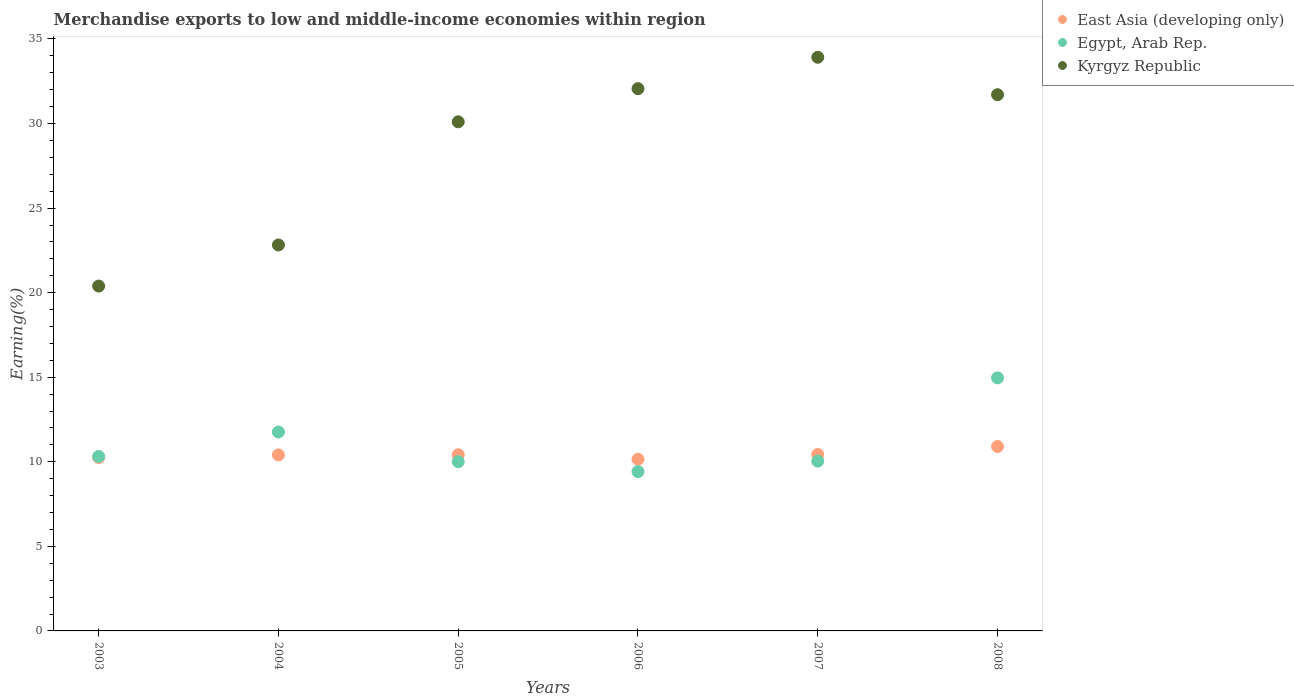What is the percentage of amount earned from merchandise exports in East Asia (developing only) in 2007?
Give a very brief answer. 10.44. Across all years, what is the maximum percentage of amount earned from merchandise exports in Egypt, Arab Rep.?
Give a very brief answer. 14.96. Across all years, what is the minimum percentage of amount earned from merchandise exports in East Asia (developing only)?
Give a very brief answer. 10.15. In which year was the percentage of amount earned from merchandise exports in East Asia (developing only) minimum?
Provide a short and direct response. 2006. What is the total percentage of amount earned from merchandise exports in Egypt, Arab Rep. in the graph?
Give a very brief answer. 66.51. What is the difference between the percentage of amount earned from merchandise exports in Kyrgyz Republic in 2003 and that in 2008?
Offer a very short reply. -11.32. What is the difference between the percentage of amount earned from merchandise exports in Egypt, Arab Rep. in 2004 and the percentage of amount earned from merchandise exports in Kyrgyz Republic in 2005?
Your answer should be very brief. -18.34. What is the average percentage of amount earned from merchandise exports in Kyrgyz Republic per year?
Provide a succinct answer. 28.5. In the year 2008, what is the difference between the percentage of amount earned from merchandise exports in East Asia (developing only) and percentage of amount earned from merchandise exports in Egypt, Arab Rep.?
Give a very brief answer. -4.06. In how many years, is the percentage of amount earned from merchandise exports in Kyrgyz Republic greater than 8 %?
Your answer should be very brief. 6. What is the ratio of the percentage of amount earned from merchandise exports in Egypt, Arab Rep. in 2005 to that in 2008?
Your response must be concise. 0.67. Is the percentage of amount earned from merchandise exports in Egypt, Arab Rep. in 2005 less than that in 2007?
Your answer should be compact. Yes. Is the difference between the percentage of amount earned from merchandise exports in East Asia (developing only) in 2006 and 2008 greater than the difference between the percentage of amount earned from merchandise exports in Egypt, Arab Rep. in 2006 and 2008?
Your answer should be very brief. Yes. What is the difference between the highest and the second highest percentage of amount earned from merchandise exports in Kyrgyz Republic?
Offer a terse response. 1.85. What is the difference between the highest and the lowest percentage of amount earned from merchandise exports in East Asia (developing only)?
Provide a succinct answer. 0.75. Is the sum of the percentage of amount earned from merchandise exports in Kyrgyz Republic in 2003 and 2005 greater than the maximum percentage of amount earned from merchandise exports in East Asia (developing only) across all years?
Provide a succinct answer. Yes. Does the percentage of amount earned from merchandise exports in East Asia (developing only) monotonically increase over the years?
Offer a terse response. No. How many years are there in the graph?
Provide a short and direct response. 6. Are the values on the major ticks of Y-axis written in scientific E-notation?
Offer a very short reply. No. Does the graph contain grids?
Your response must be concise. No. What is the title of the graph?
Ensure brevity in your answer.  Merchandise exports to low and middle-income economies within region. Does "Micronesia" appear as one of the legend labels in the graph?
Provide a short and direct response. No. What is the label or title of the Y-axis?
Your response must be concise. Earning(%). What is the Earning(%) of East Asia (developing only) in 2003?
Your answer should be very brief. 10.25. What is the Earning(%) in Egypt, Arab Rep. in 2003?
Your answer should be very brief. 10.31. What is the Earning(%) of Kyrgyz Republic in 2003?
Make the answer very short. 20.39. What is the Earning(%) of East Asia (developing only) in 2004?
Ensure brevity in your answer.  10.41. What is the Earning(%) of Egypt, Arab Rep. in 2004?
Give a very brief answer. 11.76. What is the Earning(%) in Kyrgyz Republic in 2004?
Ensure brevity in your answer.  22.82. What is the Earning(%) of East Asia (developing only) in 2005?
Your answer should be very brief. 10.42. What is the Earning(%) of Egypt, Arab Rep. in 2005?
Make the answer very short. 10.01. What is the Earning(%) in Kyrgyz Republic in 2005?
Give a very brief answer. 30.1. What is the Earning(%) of East Asia (developing only) in 2006?
Provide a succinct answer. 10.15. What is the Earning(%) in Egypt, Arab Rep. in 2006?
Your response must be concise. 9.42. What is the Earning(%) in Kyrgyz Republic in 2006?
Your answer should be very brief. 32.06. What is the Earning(%) in East Asia (developing only) in 2007?
Your response must be concise. 10.44. What is the Earning(%) of Egypt, Arab Rep. in 2007?
Your answer should be compact. 10.04. What is the Earning(%) of Kyrgyz Republic in 2007?
Your answer should be very brief. 33.92. What is the Earning(%) of East Asia (developing only) in 2008?
Keep it short and to the point. 10.9. What is the Earning(%) in Egypt, Arab Rep. in 2008?
Provide a short and direct response. 14.96. What is the Earning(%) of Kyrgyz Republic in 2008?
Keep it short and to the point. 31.71. Across all years, what is the maximum Earning(%) of East Asia (developing only)?
Make the answer very short. 10.9. Across all years, what is the maximum Earning(%) of Egypt, Arab Rep.?
Your response must be concise. 14.96. Across all years, what is the maximum Earning(%) of Kyrgyz Republic?
Make the answer very short. 33.92. Across all years, what is the minimum Earning(%) in East Asia (developing only)?
Your answer should be very brief. 10.15. Across all years, what is the minimum Earning(%) of Egypt, Arab Rep.?
Keep it short and to the point. 9.42. Across all years, what is the minimum Earning(%) in Kyrgyz Republic?
Give a very brief answer. 20.39. What is the total Earning(%) in East Asia (developing only) in the graph?
Your answer should be compact. 62.56. What is the total Earning(%) in Egypt, Arab Rep. in the graph?
Your response must be concise. 66.51. What is the total Earning(%) of Kyrgyz Republic in the graph?
Provide a succinct answer. 171. What is the difference between the Earning(%) in East Asia (developing only) in 2003 and that in 2004?
Provide a succinct answer. -0.16. What is the difference between the Earning(%) of Egypt, Arab Rep. in 2003 and that in 2004?
Your answer should be compact. -1.45. What is the difference between the Earning(%) of Kyrgyz Republic in 2003 and that in 2004?
Offer a very short reply. -2.43. What is the difference between the Earning(%) in East Asia (developing only) in 2003 and that in 2005?
Keep it short and to the point. -0.17. What is the difference between the Earning(%) in Egypt, Arab Rep. in 2003 and that in 2005?
Ensure brevity in your answer.  0.31. What is the difference between the Earning(%) in Kyrgyz Republic in 2003 and that in 2005?
Offer a very short reply. -9.71. What is the difference between the Earning(%) in East Asia (developing only) in 2003 and that in 2006?
Keep it short and to the point. 0.1. What is the difference between the Earning(%) of Egypt, Arab Rep. in 2003 and that in 2006?
Ensure brevity in your answer.  0.89. What is the difference between the Earning(%) in Kyrgyz Republic in 2003 and that in 2006?
Make the answer very short. -11.67. What is the difference between the Earning(%) of East Asia (developing only) in 2003 and that in 2007?
Provide a short and direct response. -0.19. What is the difference between the Earning(%) of Egypt, Arab Rep. in 2003 and that in 2007?
Ensure brevity in your answer.  0.27. What is the difference between the Earning(%) of Kyrgyz Republic in 2003 and that in 2007?
Provide a succinct answer. -13.53. What is the difference between the Earning(%) in East Asia (developing only) in 2003 and that in 2008?
Keep it short and to the point. -0.65. What is the difference between the Earning(%) in Egypt, Arab Rep. in 2003 and that in 2008?
Your answer should be very brief. -4.65. What is the difference between the Earning(%) in Kyrgyz Republic in 2003 and that in 2008?
Your response must be concise. -11.32. What is the difference between the Earning(%) of East Asia (developing only) in 2004 and that in 2005?
Your answer should be compact. -0.01. What is the difference between the Earning(%) in Egypt, Arab Rep. in 2004 and that in 2005?
Make the answer very short. 1.76. What is the difference between the Earning(%) in Kyrgyz Republic in 2004 and that in 2005?
Give a very brief answer. -7.28. What is the difference between the Earning(%) in East Asia (developing only) in 2004 and that in 2006?
Provide a succinct answer. 0.25. What is the difference between the Earning(%) in Egypt, Arab Rep. in 2004 and that in 2006?
Your response must be concise. 2.34. What is the difference between the Earning(%) of Kyrgyz Republic in 2004 and that in 2006?
Ensure brevity in your answer.  -9.24. What is the difference between the Earning(%) in East Asia (developing only) in 2004 and that in 2007?
Give a very brief answer. -0.03. What is the difference between the Earning(%) of Egypt, Arab Rep. in 2004 and that in 2007?
Ensure brevity in your answer.  1.72. What is the difference between the Earning(%) of Kyrgyz Republic in 2004 and that in 2007?
Offer a very short reply. -11.1. What is the difference between the Earning(%) of East Asia (developing only) in 2004 and that in 2008?
Make the answer very short. -0.5. What is the difference between the Earning(%) in Egypt, Arab Rep. in 2004 and that in 2008?
Your answer should be compact. -3.2. What is the difference between the Earning(%) of Kyrgyz Republic in 2004 and that in 2008?
Your answer should be compact. -8.89. What is the difference between the Earning(%) in East Asia (developing only) in 2005 and that in 2006?
Your answer should be compact. 0.27. What is the difference between the Earning(%) of Egypt, Arab Rep. in 2005 and that in 2006?
Provide a short and direct response. 0.58. What is the difference between the Earning(%) in Kyrgyz Republic in 2005 and that in 2006?
Provide a succinct answer. -1.96. What is the difference between the Earning(%) in East Asia (developing only) in 2005 and that in 2007?
Your answer should be very brief. -0.02. What is the difference between the Earning(%) of Egypt, Arab Rep. in 2005 and that in 2007?
Give a very brief answer. -0.04. What is the difference between the Earning(%) in Kyrgyz Republic in 2005 and that in 2007?
Your response must be concise. -3.81. What is the difference between the Earning(%) in East Asia (developing only) in 2005 and that in 2008?
Keep it short and to the point. -0.48. What is the difference between the Earning(%) in Egypt, Arab Rep. in 2005 and that in 2008?
Offer a very short reply. -4.96. What is the difference between the Earning(%) of Kyrgyz Republic in 2005 and that in 2008?
Provide a succinct answer. -1.6. What is the difference between the Earning(%) of East Asia (developing only) in 2006 and that in 2007?
Your answer should be compact. -0.28. What is the difference between the Earning(%) of Egypt, Arab Rep. in 2006 and that in 2007?
Offer a very short reply. -0.62. What is the difference between the Earning(%) in Kyrgyz Republic in 2006 and that in 2007?
Provide a succinct answer. -1.85. What is the difference between the Earning(%) of East Asia (developing only) in 2006 and that in 2008?
Make the answer very short. -0.75. What is the difference between the Earning(%) of Egypt, Arab Rep. in 2006 and that in 2008?
Make the answer very short. -5.54. What is the difference between the Earning(%) of Kyrgyz Republic in 2006 and that in 2008?
Your answer should be very brief. 0.36. What is the difference between the Earning(%) in East Asia (developing only) in 2007 and that in 2008?
Offer a very short reply. -0.47. What is the difference between the Earning(%) of Egypt, Arab Rep. in 2007 and that in 2008?
Provide a succinct answer. -4.92. What is the difference between the Earning(%) in Kyrgyz Republic in 2007 and that in 2008?
Give a very brief answer. 2.21. What is the difference between the Earning(%) of East Asia (developing only) in 2003 and the Earning(%) of Egypt, Arab Rep. in 2004?
Ensure brevity in your answer.  -1.51. What is the difference between the Earning(%) in East Asia (developing only) in 2003 and the Earning(%) in Kyrgyz Republic in 2004?
Your answer should be compact. -12.57. What is the difference between the Earning(%) of Egypt, Arab Rep. in 2003 and the Earning(%) of Kyrgyz Republic in 2004?
Your response must be concise. -12.51. What is the difference between the Earning(%) in East Asia (developing only) in 2003 and the Earning(%) in Egypt, Arab Rep. in 2005?
Your answer should be compact. 0.24. What is the difference between the Earning(%) in East Asia (developing only) in 2003 and the Earning(%) in Kyrgyz Republic in 2005?
Provide a succinct answer. -19.85. What is the difference between the Earning(%) in Egypt, Arab Rep. in 2003 and the Earning(%) in Kyrgyz Republic in 2005?
Offer a terse response. -19.79. What is the difference between the Earning(%) in East Asia (developing only) in 2003 and the Earning(%) in Egypt, Arab Rep. in 2006?
Your answer should be compact. 0.83. What is the difference between the Earning(%) of East Asia (developing only) in 2003 and the Earning(%) of Kyrgyz Republic in 2006?
Make the answer very short. -21.81. What is the difference between the Earning(%) in Egypt, Arab Rep. in 2003 and the Earning(%) in Kyrgyz Republic in 2006?
Provide a short and direct response. -21.75. What is the difference between the Earning(%) of East Asia (developing only) in 2003 and the Earning(%) of Egypt, Arab Rep. in 2007?
Ensure brevity in your answer.  0.21. What is the difference between the Earning(%) of East Asia (developing only) in 2003 and the Earning(%) of Kyrgyz Republic in 2007?
Your answer should be compact. -23.67. What is the difference between the Earning(%) of Egypt, Arab Rep. in 2003 and the Earning(%) of Kyrgyz Republic in 2007?
Give a very brief answer. -23.6. What is the difference between the Earning(%) of East Asia (developing only) in 2003 and the Earning(%) of Egypt, Arab Rep. in 2008?
Give a very brief answer. -4.71. What is the difference between the Earning(%) in East Asia (developing only) in 2003 and the Earning(%) in Kyrgyz Republic in 2008?
Provide a short and direct response. -21.46. What is the difference between the Earning(%) of Egypt, Arab Rep. in 2003 and the Earning(%) of Kyrgyz Republic in 2008?
Your answer should be compact. -21.39. What is the difference between the Earning(%) of East Asia (developing only) in 2004 and the Earning(%) of Egypt, Arab Rep. in 2005?
Provide a short and direct response. 0.4. What is the difference between the Earning(%) of East Asia (developing only) in 2004 and the Earning(%) of Kyrgyz Republic in 2005?
Provide a succinct answer. -19.7. What is the difference between the Earning(%) in Egypt, Arab Rep. in 2004 and the Earning(%) in Kyrgyz Republic in 2005?
Make the answer very short. -18.34. What is the difference between the Earning(%) of East Asia (developing only) in 2004 and the Earning(%) of Egypt, Arab Rep. in 2006?
Give a very brief answer. 0.98. What is the difference between the Earning(%) of East Asia (developing only) in 2004 and the Earning(%) of Kyrgyz Republic in 2006?
Your answer should be very brief. -21.66. What is the difference between the Earning(%) of Egypt, Arab Rep. in 2004 and the Earning(%) of Kyrgyz Republic in 2006?
Give a very brief answer. -20.3. What is the difference between the Earning(%) in East Asia (developing only) in 2004 and the Earning(%) in Egypt, Arab Rep. in 2007?
Provide a succinct answer. 0.36. What is the difference between the Earning(%) of East Asia (developing only) in 2004 and the Earning(%) of Kyrgyz Republic in 2007?
Give a very brief answer. -23.51. What is the difference between the Earning(%) of Egypt, Arab Rep. in 2004 and the Earning(%) of Kyrgyz Republic in 2007?
Your answer should be compact. -22.16. What is the difference between the Earning(%) of East Asia (developing only) in 2004 and the Earning(%) of Egypt, Arab Rep. in 2008?
Provide a succinct answer. -4.56. What is the difference between the Earning(%) of East Asia (developing only) in 2004 and the Earning(%) of Kyrgyz Republic in 2008?
Ensure brevity in your answer.  -21.3. What is the difference between the Earning(%) of Egypt, Arab Rep. in 2004 and the Earning(%) of Kyrgyz Republic in 2008?
Keep it short and to the point. -19.94. What is the difference between the Earning(%) of East Asia (developing only) in 2005 and the Earning(%) of Egypt, Arab Rep. in 2006?
Make the answer very short. 1. What is the difference between the Earning(%) of East Asia (developing only) in 2005 and the Earning(%) of Kyrgyz Republic in 2006?
Offer a terse response. -21.64. What is the difference between the Earning(%) of Egypt, Arab Rep. in 2005 and the Earning(%) of Kyrgyz Republic in 2006?
Your answer should be compact. -22.06. What is the difference between the Earning(%) in East Asia (developing only) in 2005 and the Earning(%) in Egypt, Arab Rep. in 2007?
Make the answer very short. 0.38. What is the difference between the Earning(%) of East Asia (developing only) in 2005 and the Earning(%) of Kyrgyz Republic in 2007?
Provide a succinct answer. -23.5. What is the difference between the Earning(%) of Egypt, Arab Rep. in 2005 and the Earning(%) of Kyrgyz Republic in 2007?
Your answer should be compact. -23.91. What is the difference between the Earning(%) in East Asia (developing only) in 2005 and the Earning(%) in Egypt, Arab Rep. in 2008?
Make the answer very short. -4.54. What is the difference between the Earning(%) in East Asia (developing only) in 2005 and the Earning(%) in Kyrgyz Republic in 2008?
Provide a short and direct response. -21.29. What is the difference between the Earning(%) of Egypt, Arab Rep. in 2005 and the Earning(%) of Kyrgyz Republic in 2008?
Ensure brevity in your answer.  -21.7. What is the difference between the Earning(%) of East Asia (developing only) in 2006 and the Earning(%) of Egypt, Arab Rep. in 2007?
Offer a terse response. 0.11. What is the difference between the Earning(%) of East Asia (developing only) in 2006 and the Earning(%) of Kyrgyz Republic in 2007?
Provide a succinct answer. -23.77. What is the difference between the Earning(%) of Egypt, Arab Rep. in 2006 and the Earning(%) of Kyrgyz Republic in 2007?
Your answer should be very brief. -24.5. What is the difference between the Earning(%) in East Asia (developing only) in 2006 and the Earning(%) in Egypt, Arab Rep. in 2008?
Your answer should be compact. -4.81. What is the difference between the Earning(%) of East Asia (developing only) in 2006 and the Earning(%) of Kyrgyz Republic in 2008?
Offer a terse response. -21.55. What is the difference between the Earning(%) in Egypt, Arab Rep. in 2006 and the Earning(%) in Kyrgyz Republic in 2008?
Give a very brief answer. -22.28. What is the difference between the Earning(%) in East Asia (developing only) in 2007 and the Earning(%) in Egypt, Arab Rep. in 2008?
Your answer should be compact. -4.53. What is the difference between the Earning(%) of East Asia (developing only) in 2007 and the Earning(%) of Kyrgyz Republic in 2008?
Provide a succinct answer. -21.27. What is the difference between the Earning(%) in Egypt, Arab Rep. in 2007 and the Earning(%) in Kyrgyz Republic in 2008?
Offer a terse response. -21.66. What is the average Earning(%) in East Asia (developing only) per year?
Your response must be concise. 10.43. What is the average Earning(%) in Egypt, Arab Rep. per year?
Your response must be concise. 11.08. What is the average Earning(%) of Kyrgyz Republic per year?
Provide a short and direct response. 28.5. In the year 2003, what is the difference between the Earning(%) of East Asia (developing only) and Earning(%) of Egypt, Arab Rep.?
Make the answer very short. -0.07. In the year 2003, what is the difference between the Earning(%) of East Asia (developing only) and Earning(%) of Kyrgyz Republic?
Keep it short and to the point. -10.14. In the year 2003, what is the difference between the Earning(%) of Egypt, Arab Rep. and Earning(%) of Kyrgyz Republic?
Keep it short and to the point. -10.08. In the year 2004, what is the difference between the Earning(%) of East Asia (developing only) and Earning(%) of Egypt, Arab Rep.?
Ensure brevity in your answer.  -1.36. In the year 2004, what is the difference between the Earning(%) in East Asia (developing only) and Earning(%) in Kyrgyz Republic?
Give a very brief answer. -12.41. In the year 2004, what is the difference between the Earning(%) of Egypt, Arab Rep. and Earning(%) of Kyrgyz Republic?
Your response must be concise. -11.06. In the year 2005, what is the difference between the Earning(%) in East Asia (developing only) and Earning(%) in Egypt, Arab Rep.?
Your answer should be compact. 0.41. In the year 2005, what is the difference between the Earning(%) in East Asia (developing only) and Earning(%) in Kyrgyz Republic?
Keep it short and to the point. -19.68. In the year 2005, what is the difference between the Earning(%) of Egypt, Arab Rep. and Earning(%) of Kyrgyz Republic?
Your answer should be compact. -20.1. In the year 2006, what is the difference between the Earning(%) of East Asia (developing only) and Earning(%) of Egypt, Arab Rep.?
Your answer should be compact. 0.73. In the year 2006, what is the difference between the Earning(%) in East Asia (developing only) and Earning(%) in Kyrgyz Republic?
Make the answer very short. -21.91. In the year 2006, what is the difference between the Earning(%) of Egypt, Arab Rep. and Earning(%) of Kyrgyz Republic?
Offer a terse response. -22.64. In the year 2007, what is the difference between the Earning(%) of East Asia (developing only) and Earning(%) of Egypt, Arab Rep.?
Give a very brief answer. 0.39. In the year 2007, what is the difference between the Earning(%) in East Asia (developing only) and Earning(%) in Kyrgyz Republic?
Make the answer very short. -23.48. In the year 2007, what is the difference between the Earning(%) of Egypt, Arab Rep. and Earning(%) of Kyrgyz Republic?
Offer a very short reply. -23.87. In the year 2008, what is the difference between the Earning(%) of East Asia (developing only) and Earning(%) of Egypt, Arab Rep.?
Provide a succinct answer. -4.06. In the year 2008, what is the difference between the Earning(%) in East Asia (developing only) and Earning(%) in Kyrgyz Republic?
Provide a succinct answer. -20.8. In the year 2008, what is the difference between the Earning(%) of Egypt, Arab Rep. and Earning(%) of Kyrgyz Republic?
Provide a succinct answer. -16.74. What is the ratio of the Earning(%) in East Asia (developing only) in 2003 to that in 2004?
Give a very brief answer. 0.98. What is the ratio of the Earning(%) of Egypt, Arab Rep. in 2003 to that in 2004?
Give a very brief answer. 0.88. What is the ratio of the Earning(%) in Kyrgyz Republic in 2003 to that in 2004?
Make the answer very short. 0.89. What is the ratio of the Earning(%) of East Asia (developing only) in 2003 to that in 2005?
Your response must be concise. 0.98. What is the ratio of the Earning(%) in Egypt, Arab Rep. in 2003 to that in 2005?
Make the answer very short. 1.03. What is the ratio of the Earning(%) in Kyrgyz Republic in 2003 to that in 2005?
Your answer should be compact. 0.68. What is the ratio of the Earning(%) of East Asia (developing only) in 2003 to that in 2006?
Ensure brevity in your answer.  1.01. What is the ratio of the Earning(%) in Egypt, Arab Rep. in 2003 to that in 2006?
Your answer should be very brief. 1.09. What is the ratio of the Earning(%) in Kyrgyz Republic in 2003 to that in 2006?
Your response must be concise. 0.64. What is the ratio of the Earning(%) in East Asia (developing only) in 2003 to that in 2007?
Give a very brief answer. 0.98. What is the ratio of the Earning(%) of Egypt, Arab Rep. in 2003 to that in 2007?
Give a very brief answer. 1.03. What is the ratio of the Earning(%) in Kyrgyz Republic in 2003 to that in 2007?
Provide a succinct answer. 0.6. What is the ratio of the Earning(%) in Egypt, Arab Rep. in 2003 to that in 2008?
Your answer should be compact. 0.69. What is the ratio of the Earning(%) of Kyrgyz Republic in 2003 to that in 2008?
Make the answer very short. 0.64. What is the ratio of the Earning(%) in East Asia (developing only) in 2004 to that in 2005?
Offer a terse response. 1. What is the ratio of the Earning(%) in Egypt, Arab Rep. in 2004 to that in 2005?
Make the answer very short. 1.18. What is the ratio of the Earning(%) in Kyrgyz Republic in 2004 to that in 2005?
Ensure brevity in your answer.  0.76. What is the ratio of the Earning(%) in East Asia (developing only) in 2004 to that in 2006?
Offer a terse response. 1.03. What is the ratio of the Earning(%) of Egypt, Arab Rep. in 2004 to that in 2006?
Ensure brevity in your answer.  1.25. What is the ratio of the Earning(%) of Kyrgyz Republic in 2004 to that in 2006?
Keep it short and to the point. 0.71. What is the ratio of the Earning(%) in East Asia (developing only) in 2004 to that in 2007?
Offer a very short reply. 1. What is the ratio of the Earning(%) in Egypt, Arab Rep. in 2004 to that in 2007?
Your response must be concise. 1.17. What is the ratio of the Earning(%) in Kyrgyz Republic in 2004 to that in 2007?
Give a very brief answer. 0.67. What is the ratio of the Earning(%) of East Asia (developing only) in 2004 to that in 2008?
Provide a succinct answer. 0.95. What is the ratio of the Earning(%) of Egypt, Arab Rep. in 2004 to that in 2008?
Ensure brevity in your answer.  0.79. What is the ratio of the Earning(%) of Kyrgyz Republic in 2004 to that in 2008?
Ensure brevity in your answer.  0.72. What is the ratio of the Earning(%) in East Asia (developing only) in 2005 to that in 2006?
Make the answer very short. 1.03. What is the ratio of the Earning(%) of Egypt, Arab Rep. in 2005 to that in 2006?
Keep it short and to the point. 1.06. What is the ratio of the Earning(%) in Kyrgyz Republic in 2005 to that in 2006?
Give a very brief answer. 0.94. What is the ratio of the Earning(%) in Kyrgyz Republic in 2005 to that in 2007?
Provide a succinct answer. 0.89. What is the ratio of the Earning(%) of East Asia (developing only) in 2005 to that in 2008?
Offer a very short reply. 0.96. What is the ratio of the Earning(%) in Egypt, Arab Rep. in 2005 to that in 2008?
Make the answer very short. 0.67. What is the ratio of the Earning(%) of Kyrgyz Republic in 2005 to that in 2008?
Provide a succinct answer. 0.95. What is the ratio of the Earning(%) in East Asia (developing only) in 2006 to that in 2007?
Your answer should be very brief. 0.97. What is the ratio of the Earning(%) of Egypt, Arab Rep. in 2006 to that in 2007?
Provide a short and direct response. 0.94. What is the ratio of the Earning(%) in Kyrgyz Republic in 2006 to that in 2007?
Your answer should be very brief. 0.95. What is the ratio of the Earning(%) in Egypt, Arab Rep. in 2006 to that in 2008?
Offer a terse response. 0.63. What is the ratio of the Earning(%) in Kyrgyz Republic in 2006 to that in 2008?
Provide a succinct answer. 1.01. What is the ratio of the Earning(%) of East Asia (developing only) in 2007 to that in 2008?
Make the answer very short. 0.96. What is the ratio of the Earning(%) of Egypt, Arab Rep. in 2007 to that in 2008?
Your response must be concise. 0.67. What is the ratio of the Earning(%) in Kyrgyz Republic in 2007 to that in 2008?
Provide a short and direct response. 1.07. What is the difference between the highest and the second highest Earning(%) of East Asia (developing only)?
Offer a very short reply. 0.47. What is the difference between the highest and the second highest Earning(%) in Egypt, Arab Rep.?
Your response must be concise. 3.2. What is the difference between the highest and the second highest Earning(%) in Kyrgyz Republic?
Provide a succinct answer. 1.85. What is the difference between the highest and the lowest Earning(%) in East Asia (developing only)?
Give a very brief answer. 0.75. What is the difference between the highest and the lowest Earning(%) in Egypt, Arab Rep.?
Provide a succinct answer. 5.54. What is the difference between the highest and the lowest Earning(%) of Kyrgyz Republic?
Offer a terse response. 13.53. 